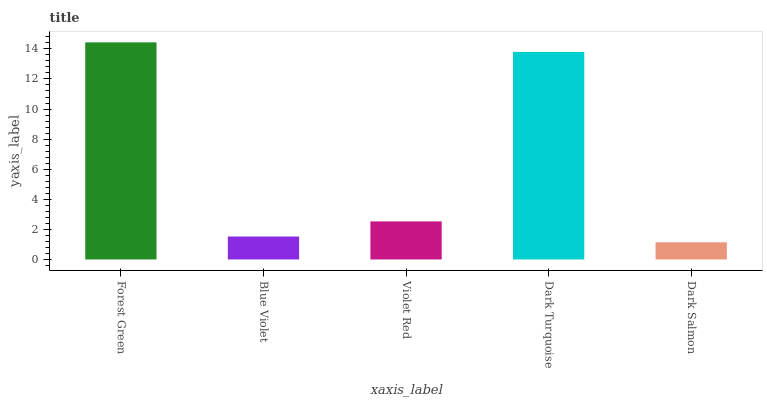Is Dark Salmon the minimum?
Answer yes or no. Yes. Is Forest Green the maximum?
Answer yes or no. Yes. Is Blue Violet the minimum?
Answer yes or no. No. Is Blue Violet the maximum?
Answer yes or no. No. Is Forest Green greater than Blue Violet?
Answer yes or no. Yes. Is Blue Violet less than Forest Green?
Answer yes or no. Yes. Is Blue Violet greater than Forest Green?
Answer yes or no. No. Is Forest Green less than Blue Violet?
Answer yes or no. No. Is Violet Red the high median?
Answer yes or no. Yes. Is Violet Red the low median?
Answer yes or no. Yes. Is Blue Violet the high median?
Answer yes or no. No. Is Blue Violet the low median?
Answer yes or no. No. 